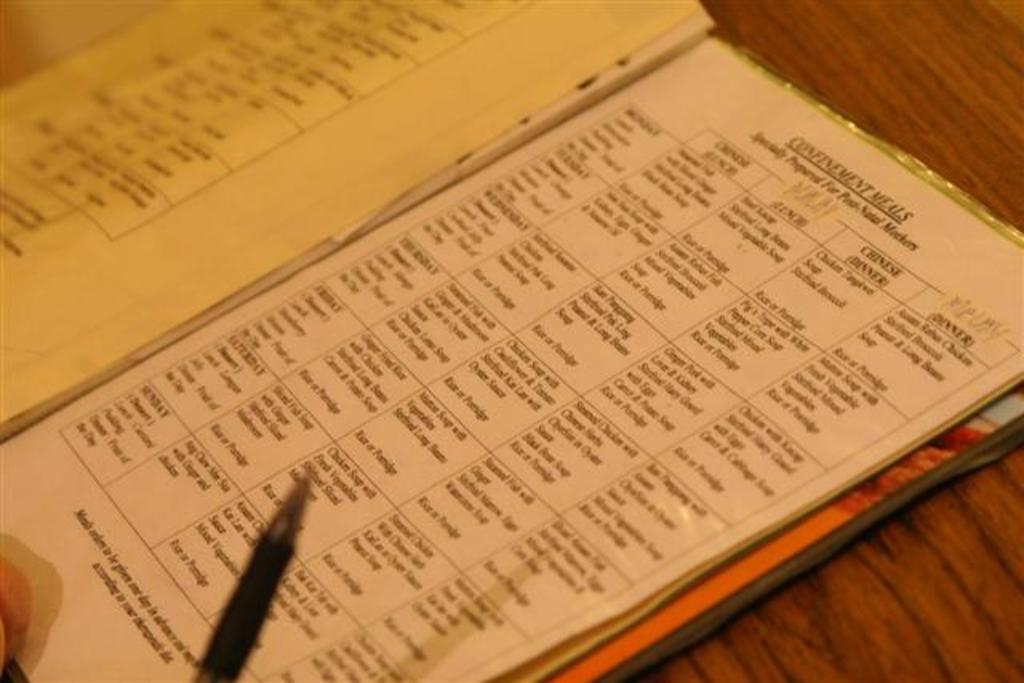<image>
Create a compact narrative representing the image presented. A pen is shown over a book open to a page about confinement meals. 